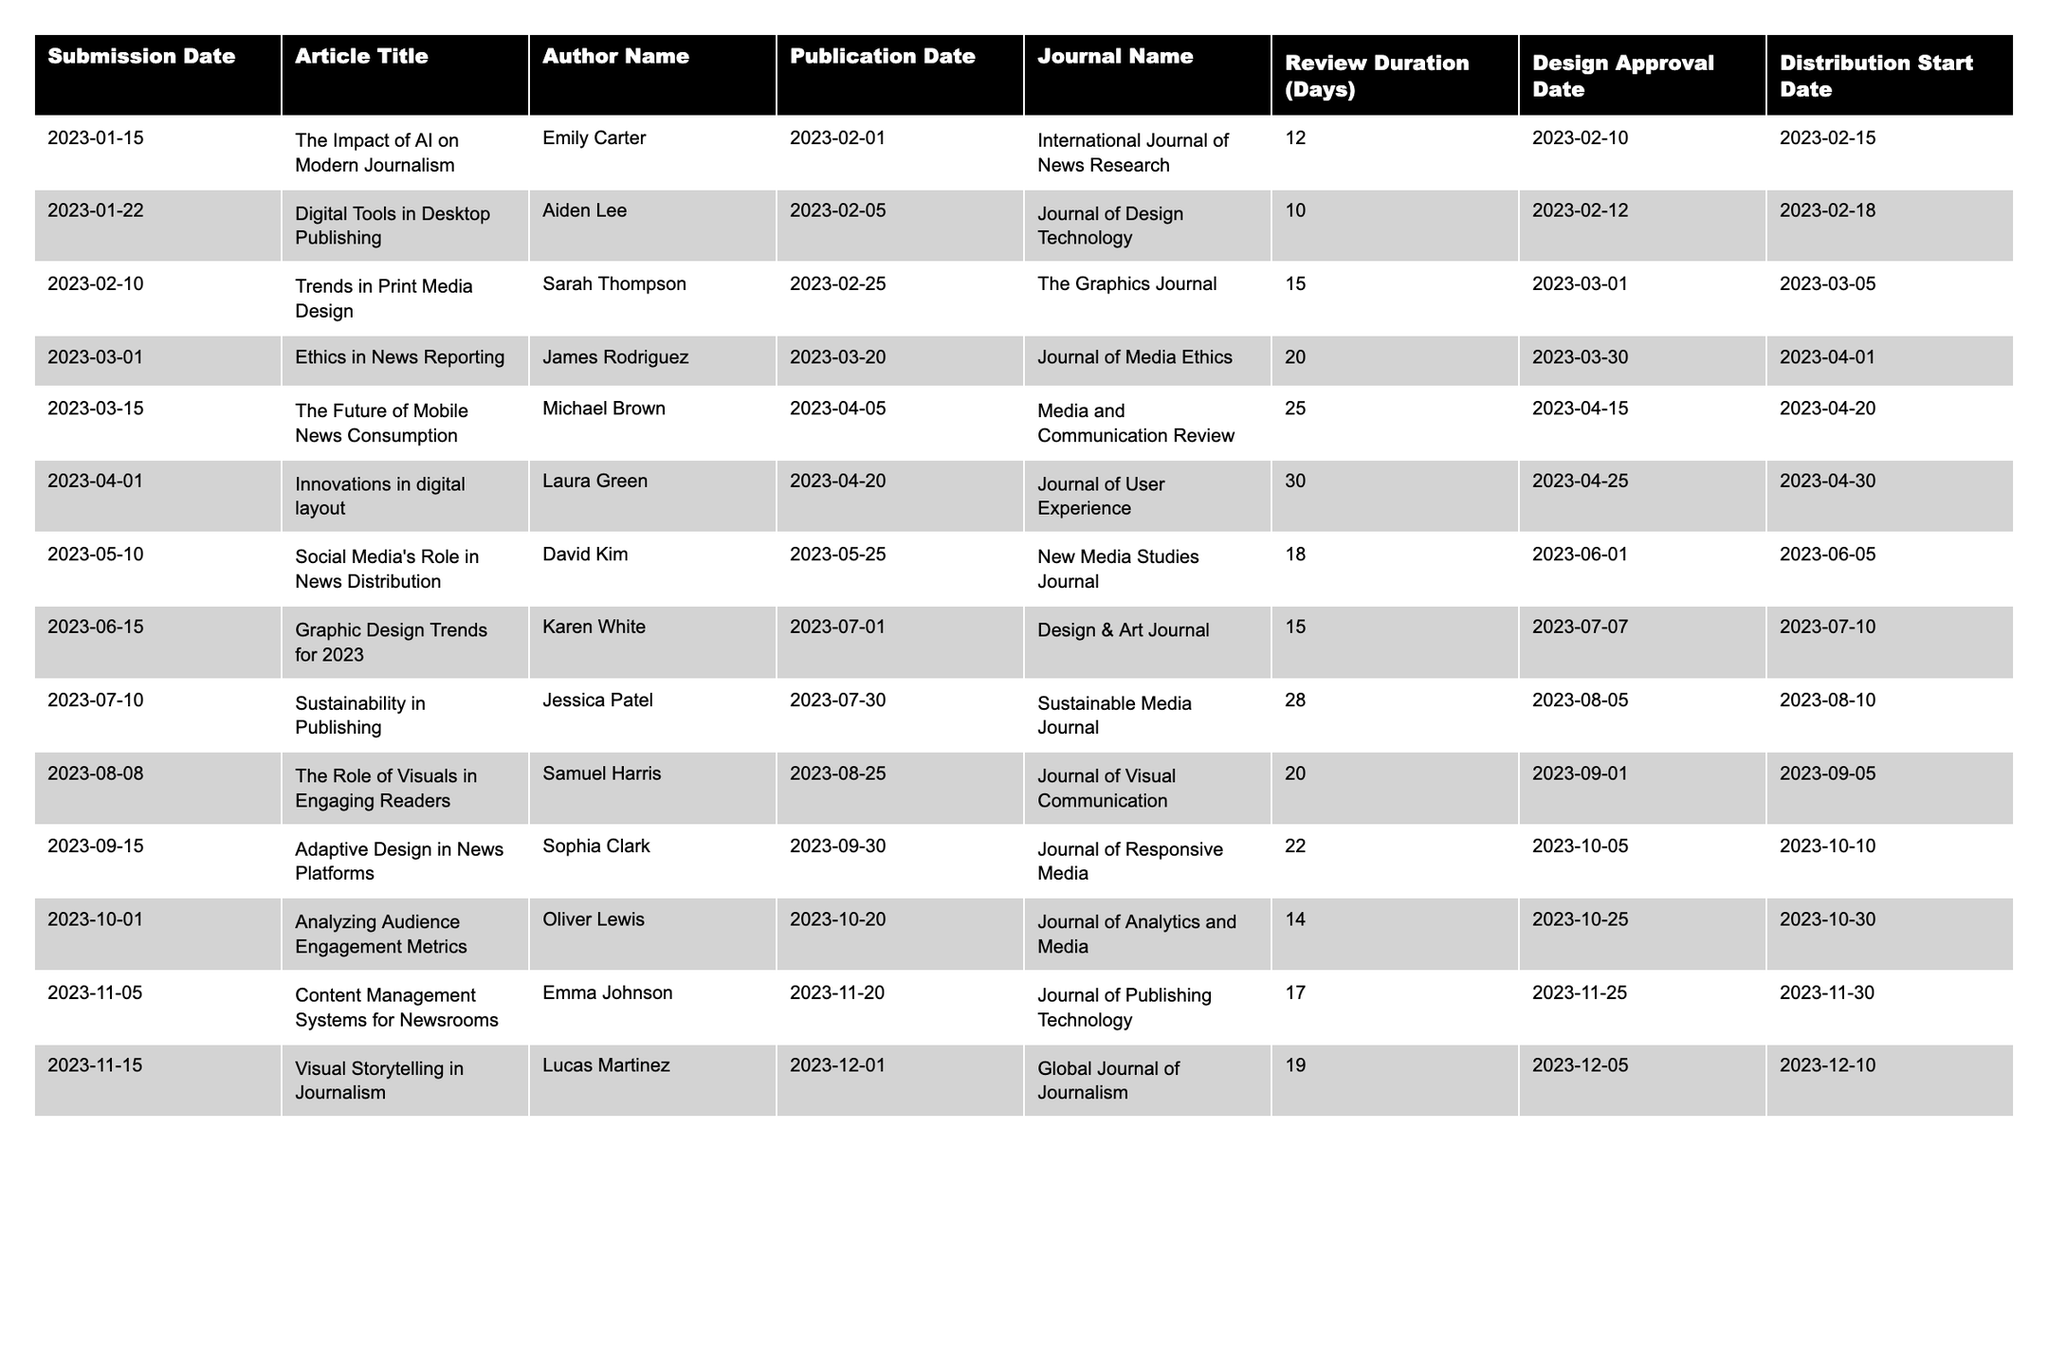What is the title of the first article submitted in 2023? The first article submitted in 2023 according to the table is "The Impact of AI on Modern Journalism," as it appears as the first entry in the Submission Date column.
Answer: The Impact of AI on Modern Journalism What is the publication date of the article titled "Adaptive Design in News Platforms"? In the table, the article "Adaptive Design in News Platforms" has a publication date listed as 2023-09-30.
Answer: 2023-09-30 How many articles were published after April 2023? By inspecting the Publication Date column, articles published after April 2023 include: "Social Media's Role in News Distribution," "Graphic Design Trends for 2023," "Sustainability in Publishing," "The Role of Visuals in Engaging Readers," "Adaptive Design in News Platforms," "Analyzing Audience Engagement Metrics," "Content Management Systems for Newsrooms," and "Visual Storytelling in Journalism." This totals to 8 articles.
Answer: 8 Which article had the longest review duration? To determine the longest review duration, I compare the values in the Review Duration (Days) column. "Innovations in digital layout" has the highest value at 30 days.
Answer: Innovations in digital layout True or False: The article "Digital Tools in Desktop Publishing" was approved for design on March 1, 2023. Checking the Design Approval Date for "Digital Tools in Desktop Publishing," the date is listed as 2023-02-12, so it is not approved on March 1, 2023. The statement is therefore false.
Answer: False What is the average review duration of all articles submitted after June 2023? The articles submitted after June 2023 are "Analyzing Audience Engagement Metrics" (14 days), "Content Management Systems for Newsrooms" (17 days), and "Visual Storytelling in Journalism" (19 days). To find the average, I calculate (14 + 17 + 19) / 3 = 16.67 days.
Answer: 16.67 How many days elapsed between the submission of "The Future of Mobile News Consumption" and its design approval? The submission date for "The Future of Mobile News Consumption" is 2023-03-15 and its design approval date is 2023-04-15. To find the number of days between these dates, I calculate the difference: 31 days.
Answer: 31 Which author has the most articles in the table? By reviewing the Author Name column, I find that researchers Emily Carter, James Rodriguez, and Lucas Martinez each have 2 articles listed, while the others have 1. Therefore, there is a tie between these authors.
Answer: Emily Carter, James Rodriguez, and Lucas Martinez What are the distribution start dates for all articles published by journals with "Media" in the title? The relevant articles are "Ethics in News Reporting," with a distribution start date of 2023-04-01, and "Sustainability in Publishing," with a start date of 2023-08-10. Thus, the distribution start dates are 2023-04-01 and 2023-08-10.
Answer: 2023-04-01 and 2023-08-10 How many days from submission to publication does "Visual Storytelling in Journalism" take? The submission date for "Visual Storytelling in Journalism" is 2023-11-15 and the publication date is 2023-12-01. To find this duration, I calculate 16 days.
Answer: 16 days 